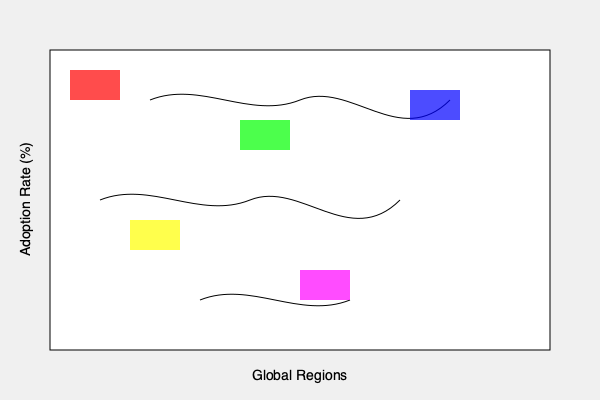Based on the color-coded world map showing adoption rates of educational software in different regions, which strategy would be most effective for global market penetration, considering the varying levels of adoption across regions? To determine the most effective strategy for global market penetration, we need to analyze the color-coded regions and their corresponding adoption rates:

1. Identify regions:
   - Red (top left): Low adoption rate
   - Green (middle): Medium-high adoption rate
   - Blue (top right): Medium adoption rate
   - Yellow (bottom left): Low-medium adoption rate
   - Purple (bottom right): High adoption rate

2. Analyze market potential:
   - High adoption areas (purple) indicate successful penetration
   - Low adoption areas (red, yellow) represent untapped markets
   - Medium adoption areas (green, blue) show room for growth

3. Consider market entry strategies:
   - For low adoption regions: Intensive marketing and education campaigns
   - For medium adoption regions: Partnerships and localization efforts
   - For high adoption regions: Focus on customer retention and product improvements

4. Prioritize resources:
   - Allocate more resources to low and medium adoption areas
   - Maintain presence in high adoption areas

5. Develop a phased approach:
   - Start with medium adoption regions to build momentum
   - Expand to low adoption regions with lessons learned
   - Continuously improve offerings in high adoption regions

6. Adapt to regional differences:
   - Customize marketing messages for each region
   - Tailor product features to local educational needs
   - Address cultural and language barriers

Given these factors, the most effective strategy would be to focus on a phased, region-specific approach that prioritizes medium adoption areas for quick wins, while simultaneously developing long-term plans for low adoption regions and maintaining strong presence in high adoption areas.
Answer: Phased, region-specific approach prioritizing medium adoption areas with customized strategies for each region. 